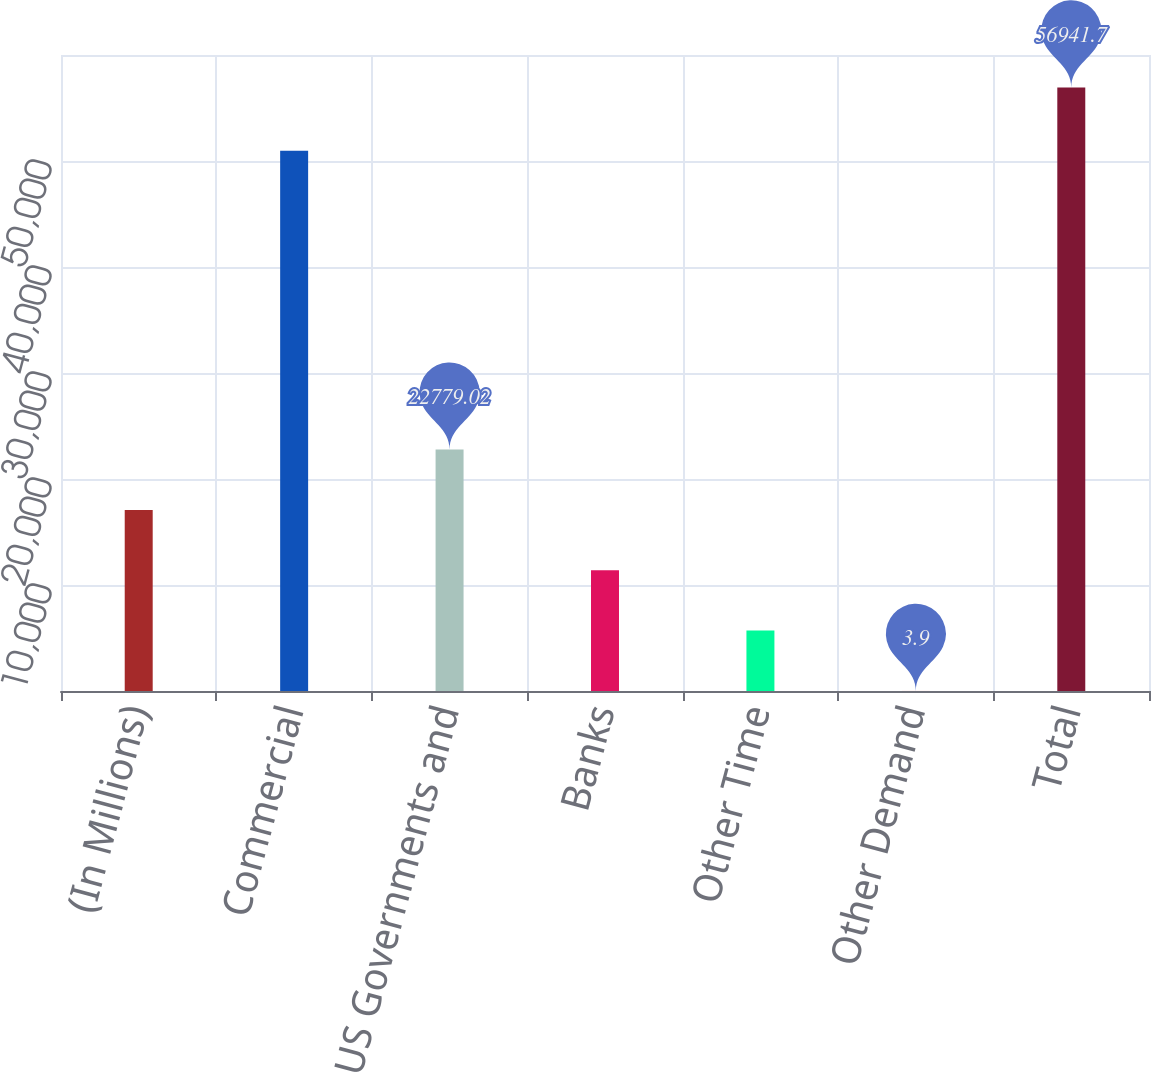<chart> <loc_0><loc_0><loc_500><loc_500><bar_chart><fcel>(In Millions)<fcel>Commercial<fcel>Non-US Governments and<fcel>Banks<fcel>Other Time<fcel>Other Demand<fcel>Total<nl><fcel>17085.2<fcel>50965.8<fcel>22779<fcel>11391.5<fcel>5697.68<fcel>3.9<fcel>56941.7<nl></chart> 